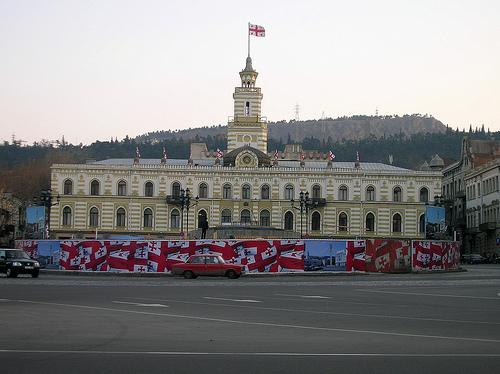Question: when was the picture taken?
Choices:
A. Evening.
B. Afternoon.
C. Morning.
D. Night.
Answer with the letter. Answer: B Question: what is on the road?
Choices:
A. Trucks.
B. Vans.
C. Cars.
D. Buses.
Answer with the letter. Answer: C Question: what color is the wall?
Choices:
A. White.
B. Red.
C. Blue.
D. Black.
Answer with the letter. Answer: B Question: where was the picture taken?
Choices:
A. Road.
B. Highway.
C. Driveway.
D. Street.
Answer with the letter. Answer: D Question: why is it light outside?
Choices:
A. Moon.
B. Stars.
C. Street lamp.
D. Sun.
Answer with the letter. Answer: D 